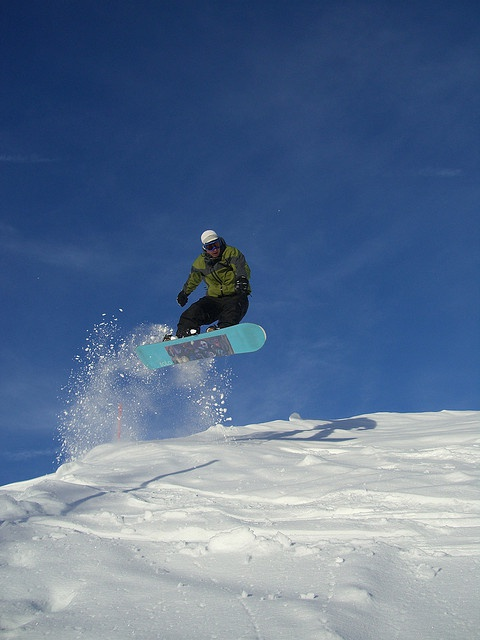Describe the objects in this image and their specific colors. I can see people in navy, black, darkgreen, blue, and gray tones and snowboard in navy, teal, gray, and darkgray tones in this image. 